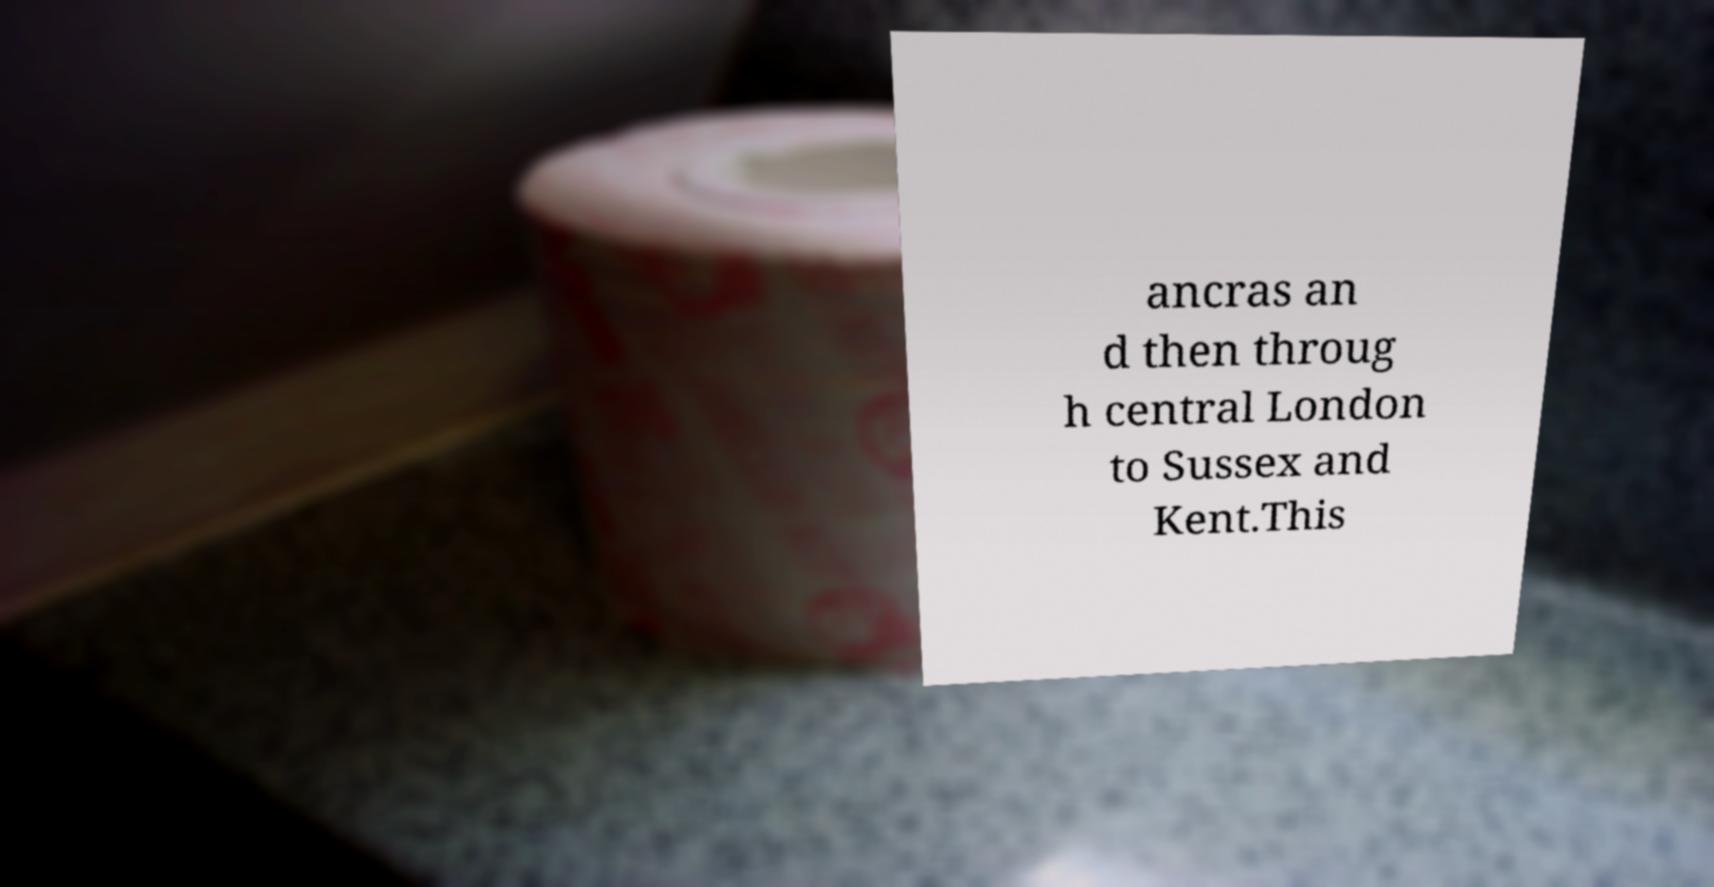Could you assist in decoding the text presented in this image and type it out clearly? ancras an d then throug h central London to Sussex and Kent.This 